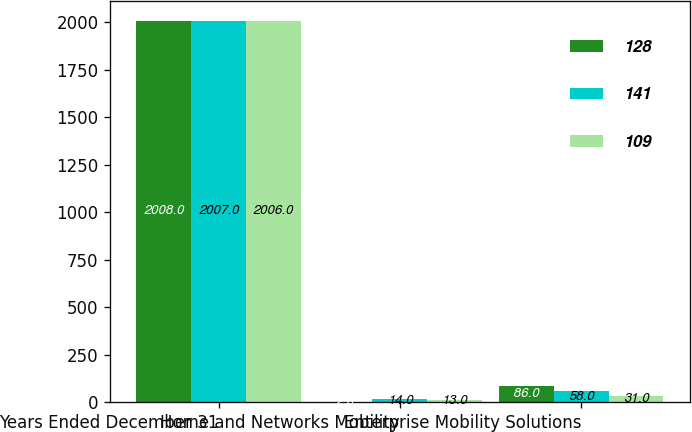Convert chart to OTSL. <chart><loc_0><loc_0><loc_500><loc_500><stacked_bar_chart><ecel><fcel>Years Ended December 31<fcel>Home and Networks Mobility<fcel>Enterprise Mobility Solutions<nl><fcel>128<fcel>2008<fcel>2<fcel>86<nl><fcel>141<fcel>2007<fcel>14<fcel>58<nl><fcel>109<fcel>2006<fcel>13<fcel>31<nl></chart> 